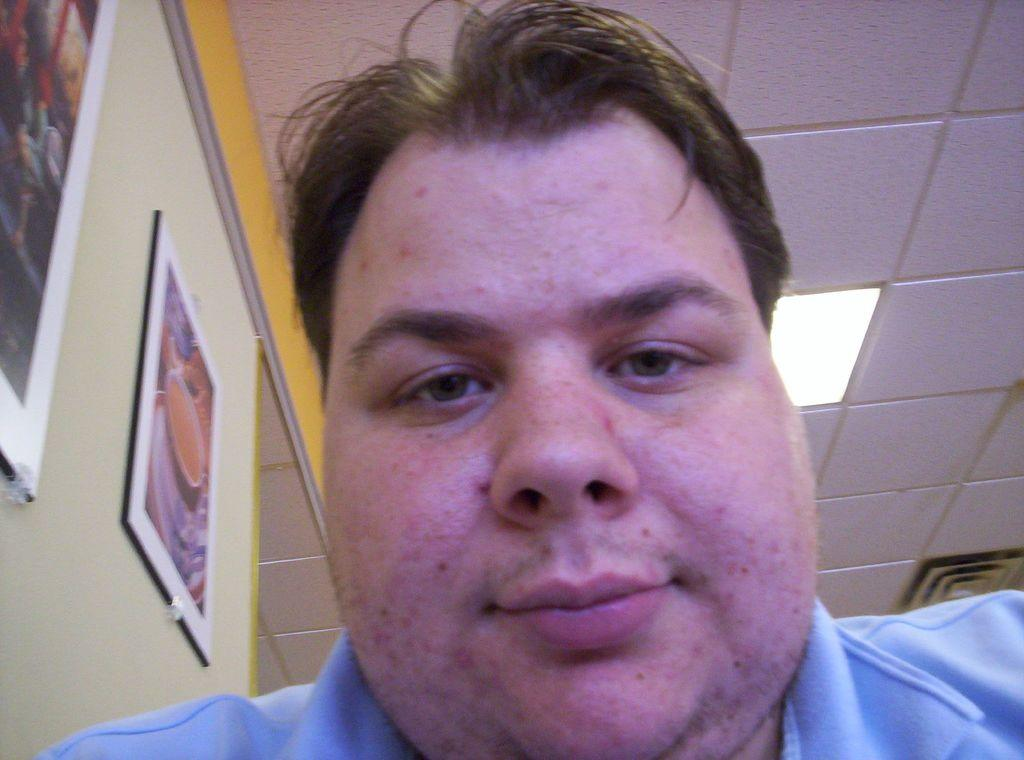What is the person in the image wearing? The person in the image is wearing a blue T-shirt. Can you describe any features of the room in the image? A light is attached to the roof, and there are two picture frames on the left side of the wall. What type of food is being approved by the person in the image? There is no food or approval process depicted in the image. 